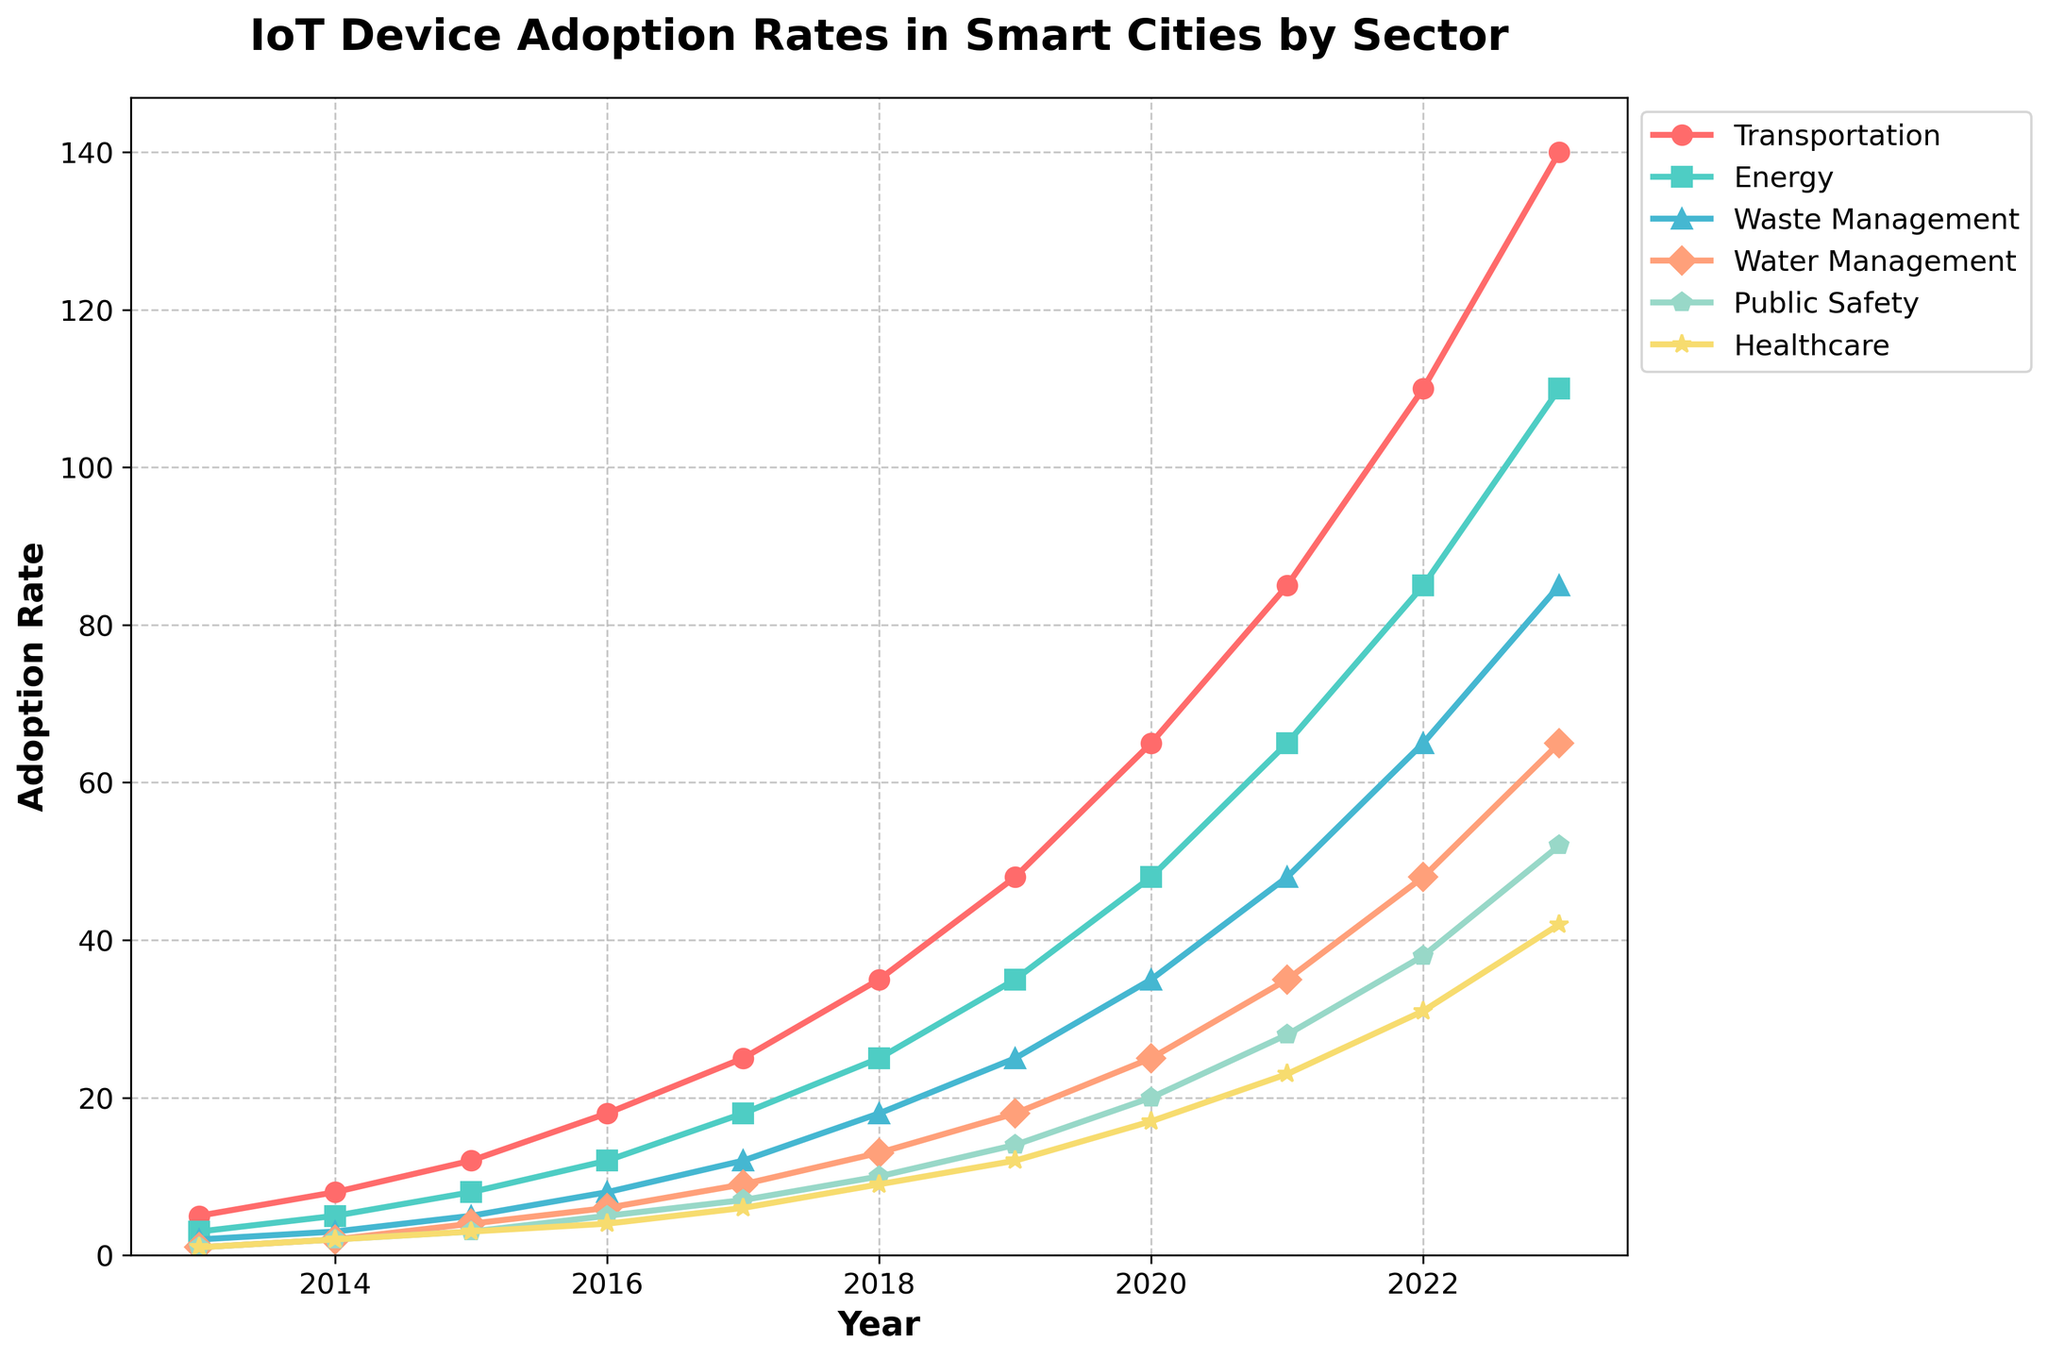What trend can be observed in the adoption rates of IoT devices in the transportation sector over the past decade? The adoption rates in the transportation sector steadily rise from 5 in 2013 to 140 in 2023. This indicates a significant growth trend over the past decade.
Answer: Significant growth In which year did the energy sector first surpass an adoption rate of 50? The energy sector crossed an adoption rate of 50 in 2021, where it reached 65. This can be seen on the Y-axis by following the energy sector's curve and finding when it surpasses the 50 mark.
Answer: 2021 How does the adoption rate in waste management in 2020 compare to that in healthcare in the same year? In 2020, the adoption rate in waste management is 35, while in healthcare, it is 17. Comparing the two, waste management has a higher adoption rate than healthcare in that year.
Answer: Waste management is higher Which sector exhibited the highest adoption rate in 2023? The transportation sector has the highest adoption rate in 2023 at 140, which can be seen by comparing the heights of the data points for each sector in 2023.
Answer: Transportation Calculate the average adoption rate of IoT devices for the public safety sector over the past decade. To find the average adoption rate for public safety, sum the values for all years (1+2+3+5+7+10+14+20+28+38+52 = 180) and divide by the number of years (11). The average adoption rate is approximately 180/11.
Answer: 16.36 What is the difference in adoption rates between the transportation and water management sectors in 2023? In 2023, the transportation sector has an adoption rate of 140, and the water management sector has an adoption rate of 65. The difference is 140 - 65.
Answer: 75 Between 2016 and 2019, which sector had the fastest growth in adoption rate, and what was the increase? The transportation sector grew from 18 in 2016 to 48 in 2019. This is an increase of 48 - 18 = 30. Other sectors had smaller increases. Thus, transportation had the fastest growth.
Answer: Transportation, 30 What is the highest adoption rate recorded for the healthcare sector, and in which year was it achieved? The highest adoption rate for the healthcare sector is 42, achieved in 2023. This can be observed by identifying the peak of the healthcare sector's line on the graph.
Answer: 42, 2023 Identify the year when water management saw its first double-digit adoption rate. Water management first achieved a double-digit adoption rate of 13 in 2018, as seen from the data marked on the graph.
Answer: 2018 Compare the total increase in adoption rates from 2013 to 2023 between the energy and public safety sectors. Which sector showed a higher overall growth? The energy sector increased from 3 in 2013 to 110 in 2023, a growth of 107. Public safety increased from 1 in 2013 to 52 in 2023, a growth of 51. Hence, the energy sector showed higher overall growth.
Answer: Energy, 107 